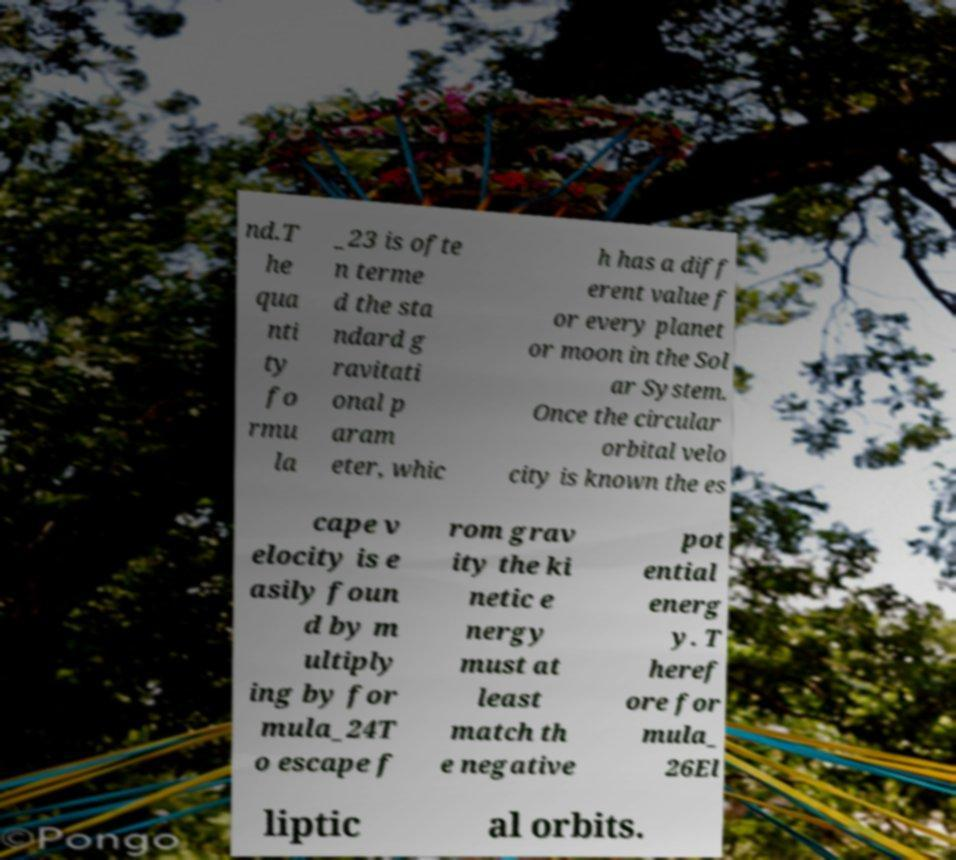Please identify and transcribe the text found in this image. nd.T he qua nti ty fo rmu la _23 is ofte n terme d the sta ndard g ravitati onal p aram eter, whic h has a diff erent value f or every planet or moon in the Sol ar System. Once the circular orbital velo city is known the es cape v elocity is e asily foun d by m ultiply ing by for mula_24T o escape f rom grav ity the ki netic e nergy must at least match th e negative pot ential energ y. T heref ore for mula_ 26El liptic al orbits. 